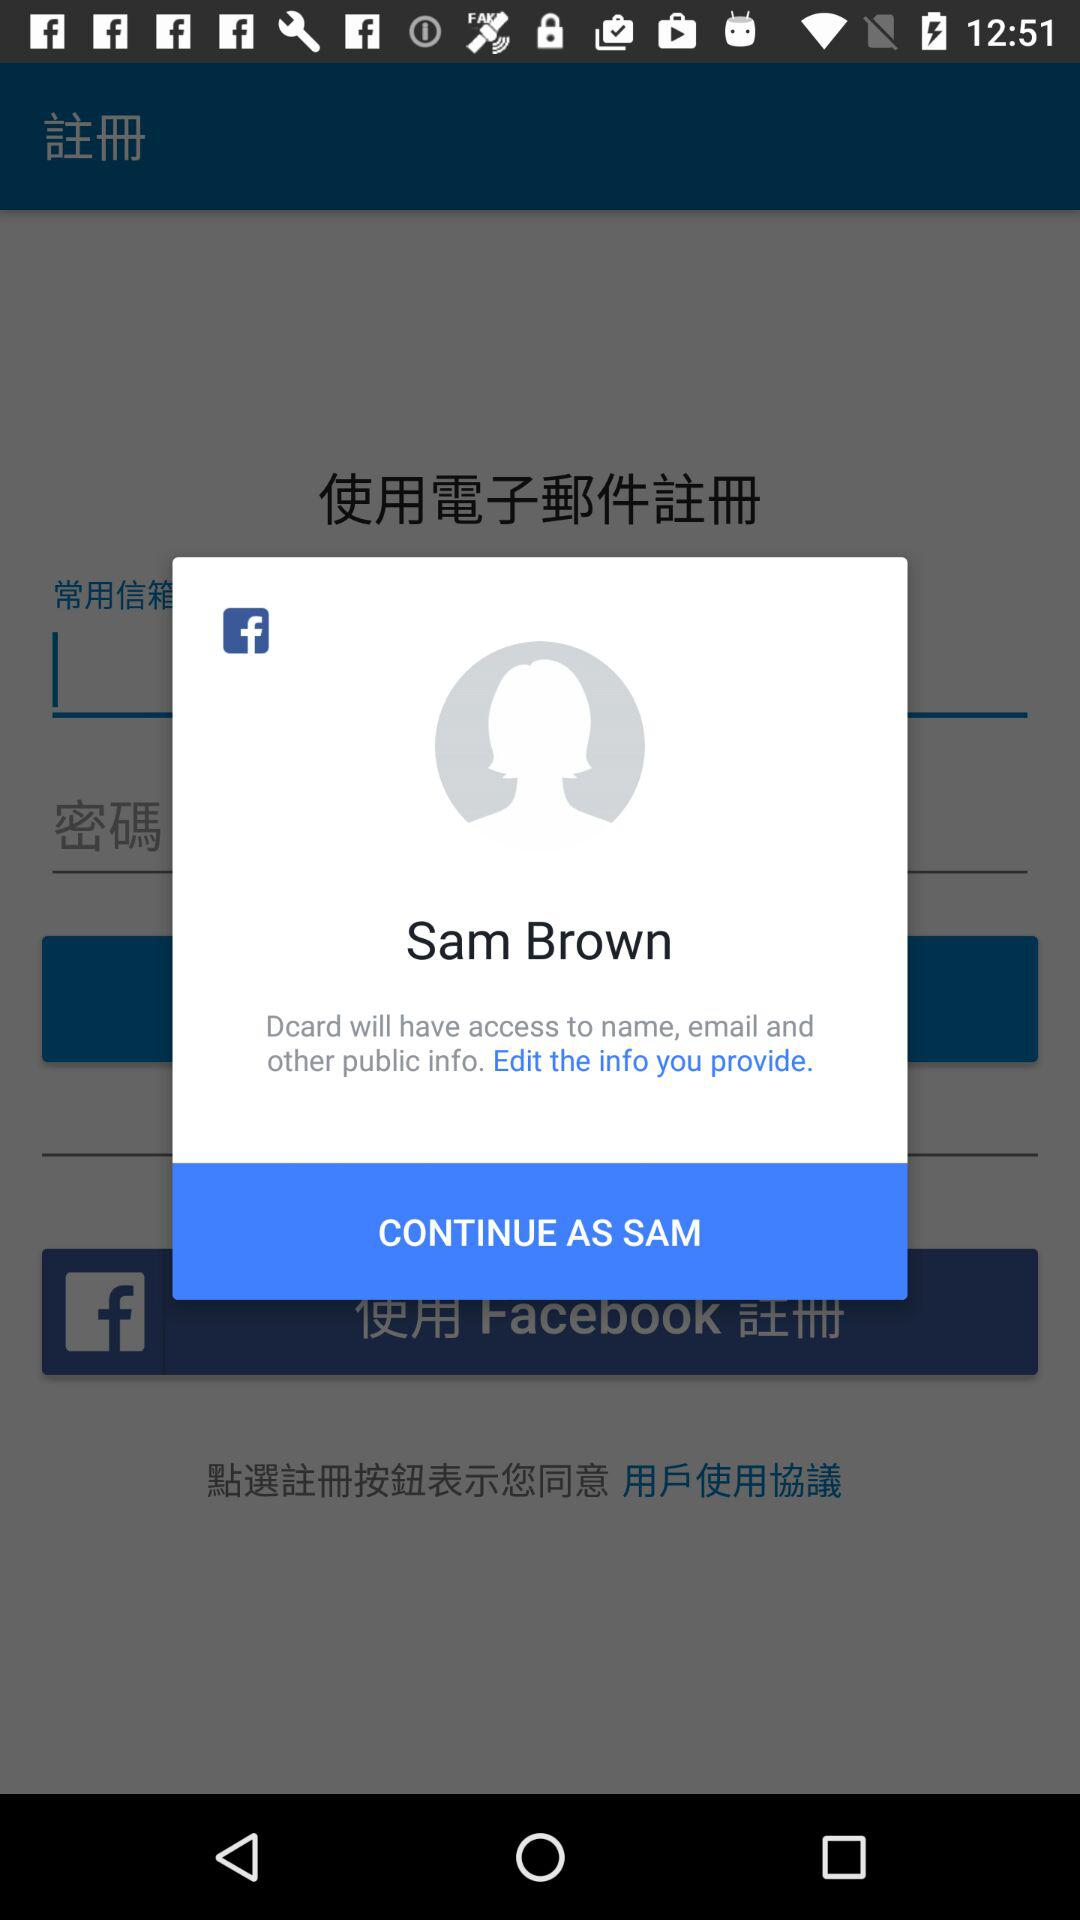What application is asking for permission? The application asking for permission is "Dcard". 